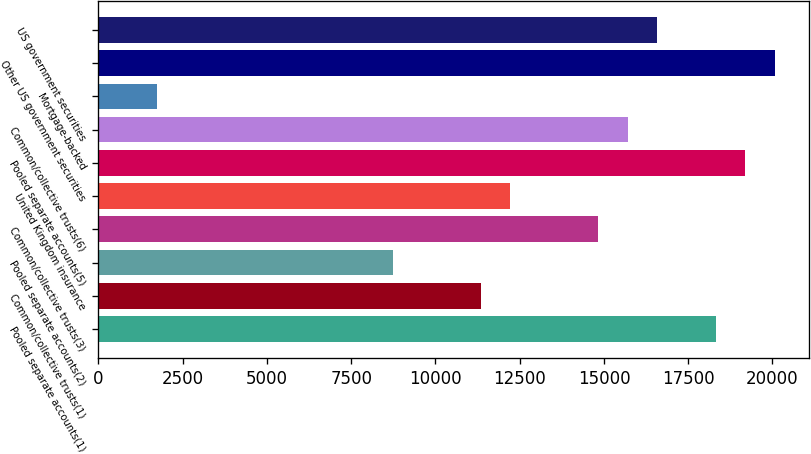<chart> <loc_0><loc_0><loc_500><loc_500><bar_chart><fcel>Pooled separate accounts(1)<fcel>Common/collective trusts(1)<fcel>Pooled separate accounts(2)<fcel>Common/collective trusts(3)<fcel>United Kingdom insurance<fcel>Pooled separate accounts(5)<fcel>Common/collective trusts(6)<fcel>Mortgage-backed<fcel>Other US government securities<fcel>US government securities<nl><fcel>18321.9<fcel>11342.4<fcel>8725.03<fcel>14832.1<fcel>12214.8<fcel>19194.3<fcel>15704.5<fcel>1745.51<fcel>20066.8<fcel>16577<nl></chart> 